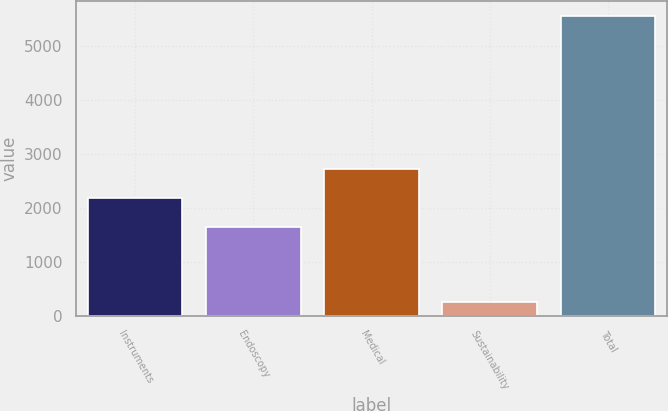Convert chart. <chart><loc_0><loc_0><loc_500><loc_500><bar_chart><fcel>Instruments<fcel>Endoscopy<fcel>Medical<fcel>Sustainability<fcel>Total<nl><fcel>2181.9<fcel>1652<fcel>2711.8<fcel>258<fcel>5557<nl></chart> 